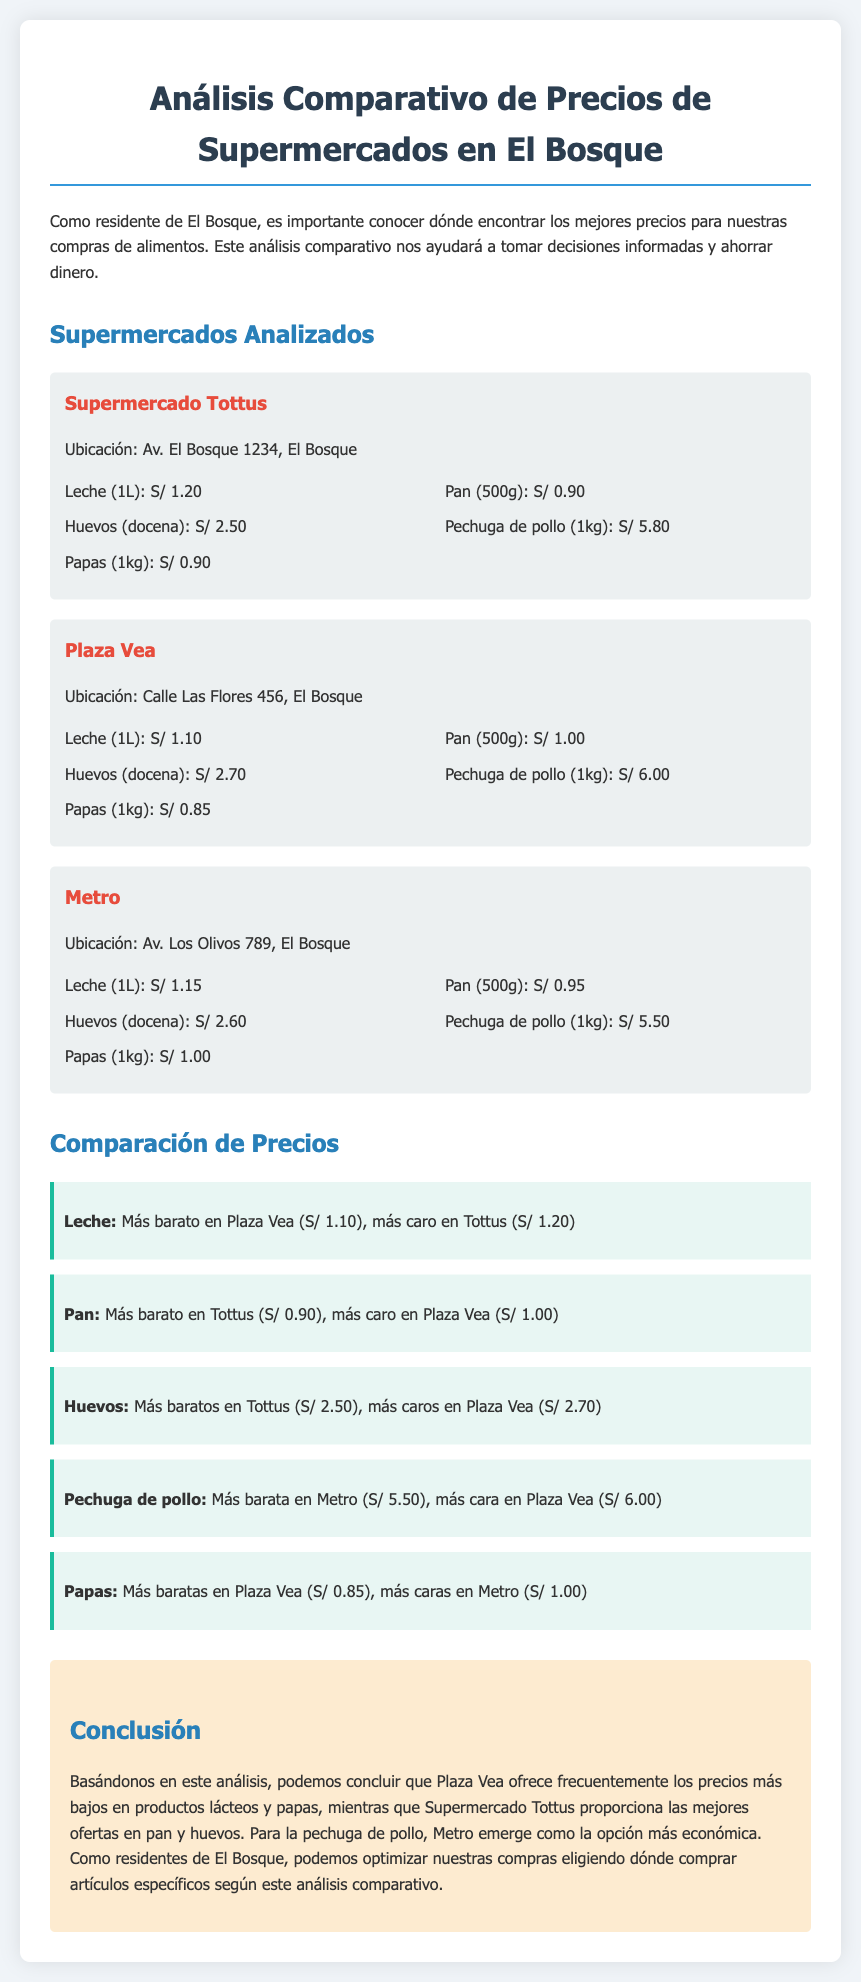¿Qué supermercado tiene la leche más barata? La leche más barata se encuentra en Plaza Vea a S/ 1.10.
Answer: Plaza Vea ¿Cuánto cuesta el pan en Tottus? En Tottus, el pan (500g) cuesta S/ 0.90.
Answer: S/ 0.90 ¿Cuál es el precio de la pechuga de pollo en Metro? El precio de la pechuga de pollo (1kg) en Metro es S/ 5.50.
Answer: S/ 5.50 ¿Qué producto es más caro en Plaza Vea? En Plaza Vea, el producto más caro mencionado es la pechuga de pollo a S/ 6.00.
Answer: Pechuga de pollo ¿Cuáles son las papas más baratas? Las papas más baratas son en Plaza Vea a S/ 0.85.
Answer: Plaza Vea ¿Cuántos supermercados se analizan en el documento? Se analizan tres supermercados: Tottus, Plaza Vea y Metro.
Answer: Tres ¿Qué conclusión se menciona sobre la pechuga de pollo? La conclusión menciona que Metro es la opción más económica para la pechuga de pollo.
Answer: Metro ¿Cuánto cuesta la docena de huevos en Tottus? La docena de huevos en Tottus cuesta S/ 2.50.
Answer: S/ 2.50 